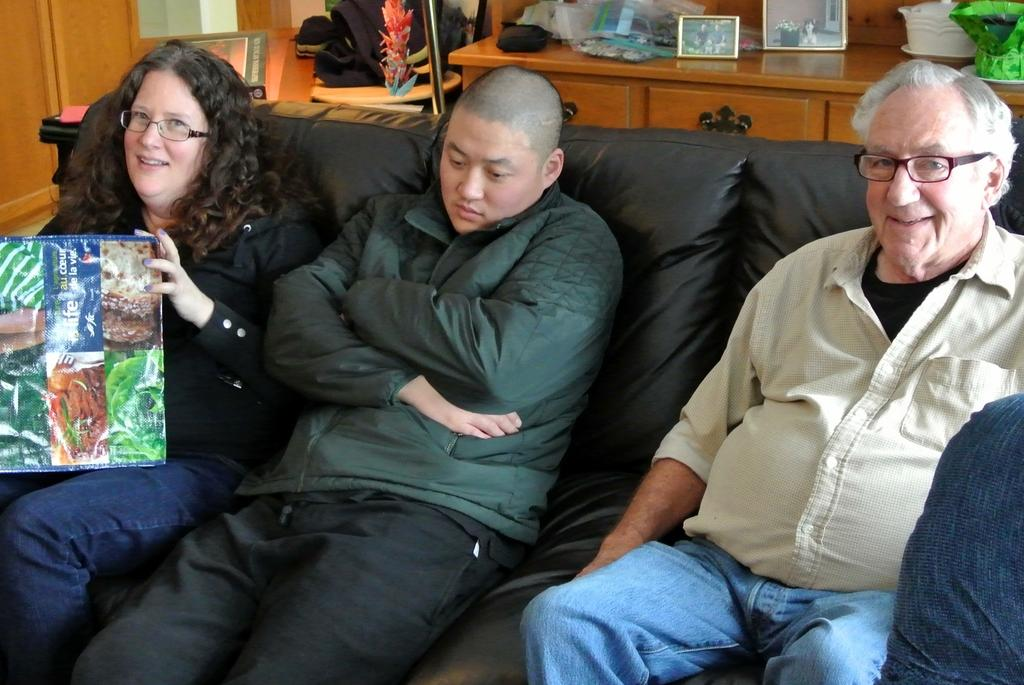How many people are in the image? There are two men and a woman in the image. What are they sitting on? They are sitting on a black sofa. What is located behind the people sitting on the sofa? There is a wooden table with photographs behind them. What is on the left side of the image? There is a cupboard on the left side of the image. What type of sweater is the yak wearing in the image? There is no yak or sweater present in the image. How many shoes can be seen on the wooden table? There are no shoes visible on the wooden table in the image. 